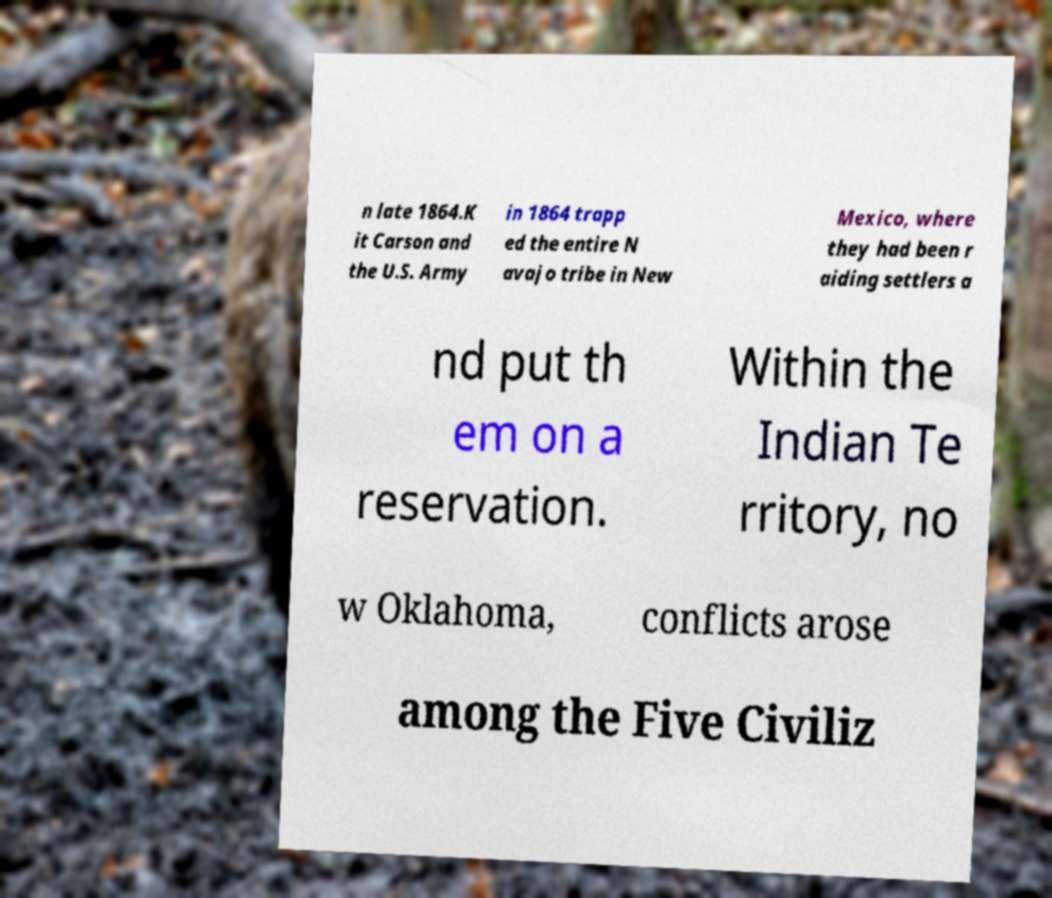Can you read and provide the text displayed in the image?This photo seems to have some interesting text. Can you extract and type it out for me? n late 1864.K it Carson and the U.S. Army in 1864 trapp ed the entire N avajo tribe in New Mexico, where they had been r aiding settlers a nd put th em on a reservation. Within the Indian Te rritory, no w Oklahoma, conflicts arose among the Five Civiliz 